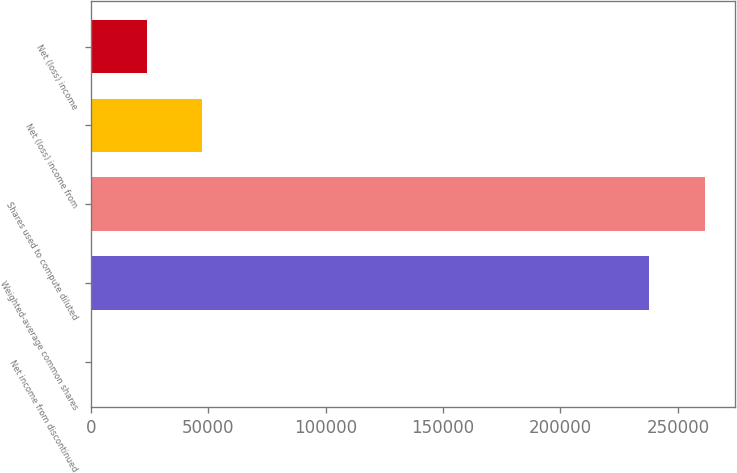Convert chart to OTSL. <chart><loc_0><loc_0><loc_500><loc_500><bar_chart><fcel>Net income from discontinued<fcel>Weighted-average common shares<fcel>Shares used to compute diluted<fcel>Net (loss) income from<fcel>Net (loss) income<nl><fcel>0.02<fcel>237707<fcel>261478<fcel>47541.4<fcel>23770.7<nl></chart> 